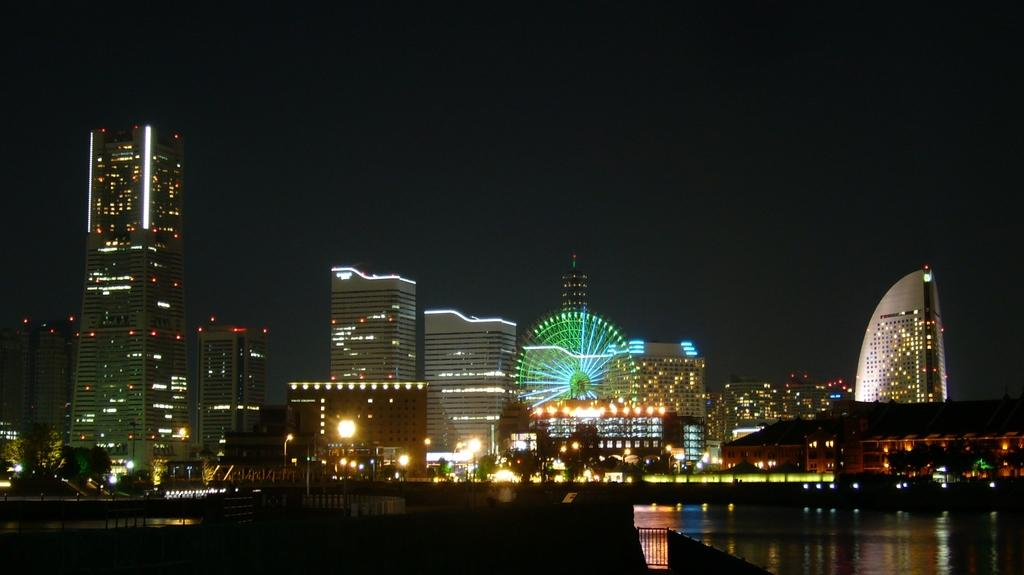What type of structures can be seen in the image? There are buildings, poles, and towers in the image. What other objects or features are present in the image? There are trees, lights, fun rides, a railing, water, and the sky visible in the image. What is the expert's opinion on the rhythm of the fun rides in the image? There is no expert or opinion on the rhythm of the fun rides in the image, as the facts provided do not mention any experts or opinions. 